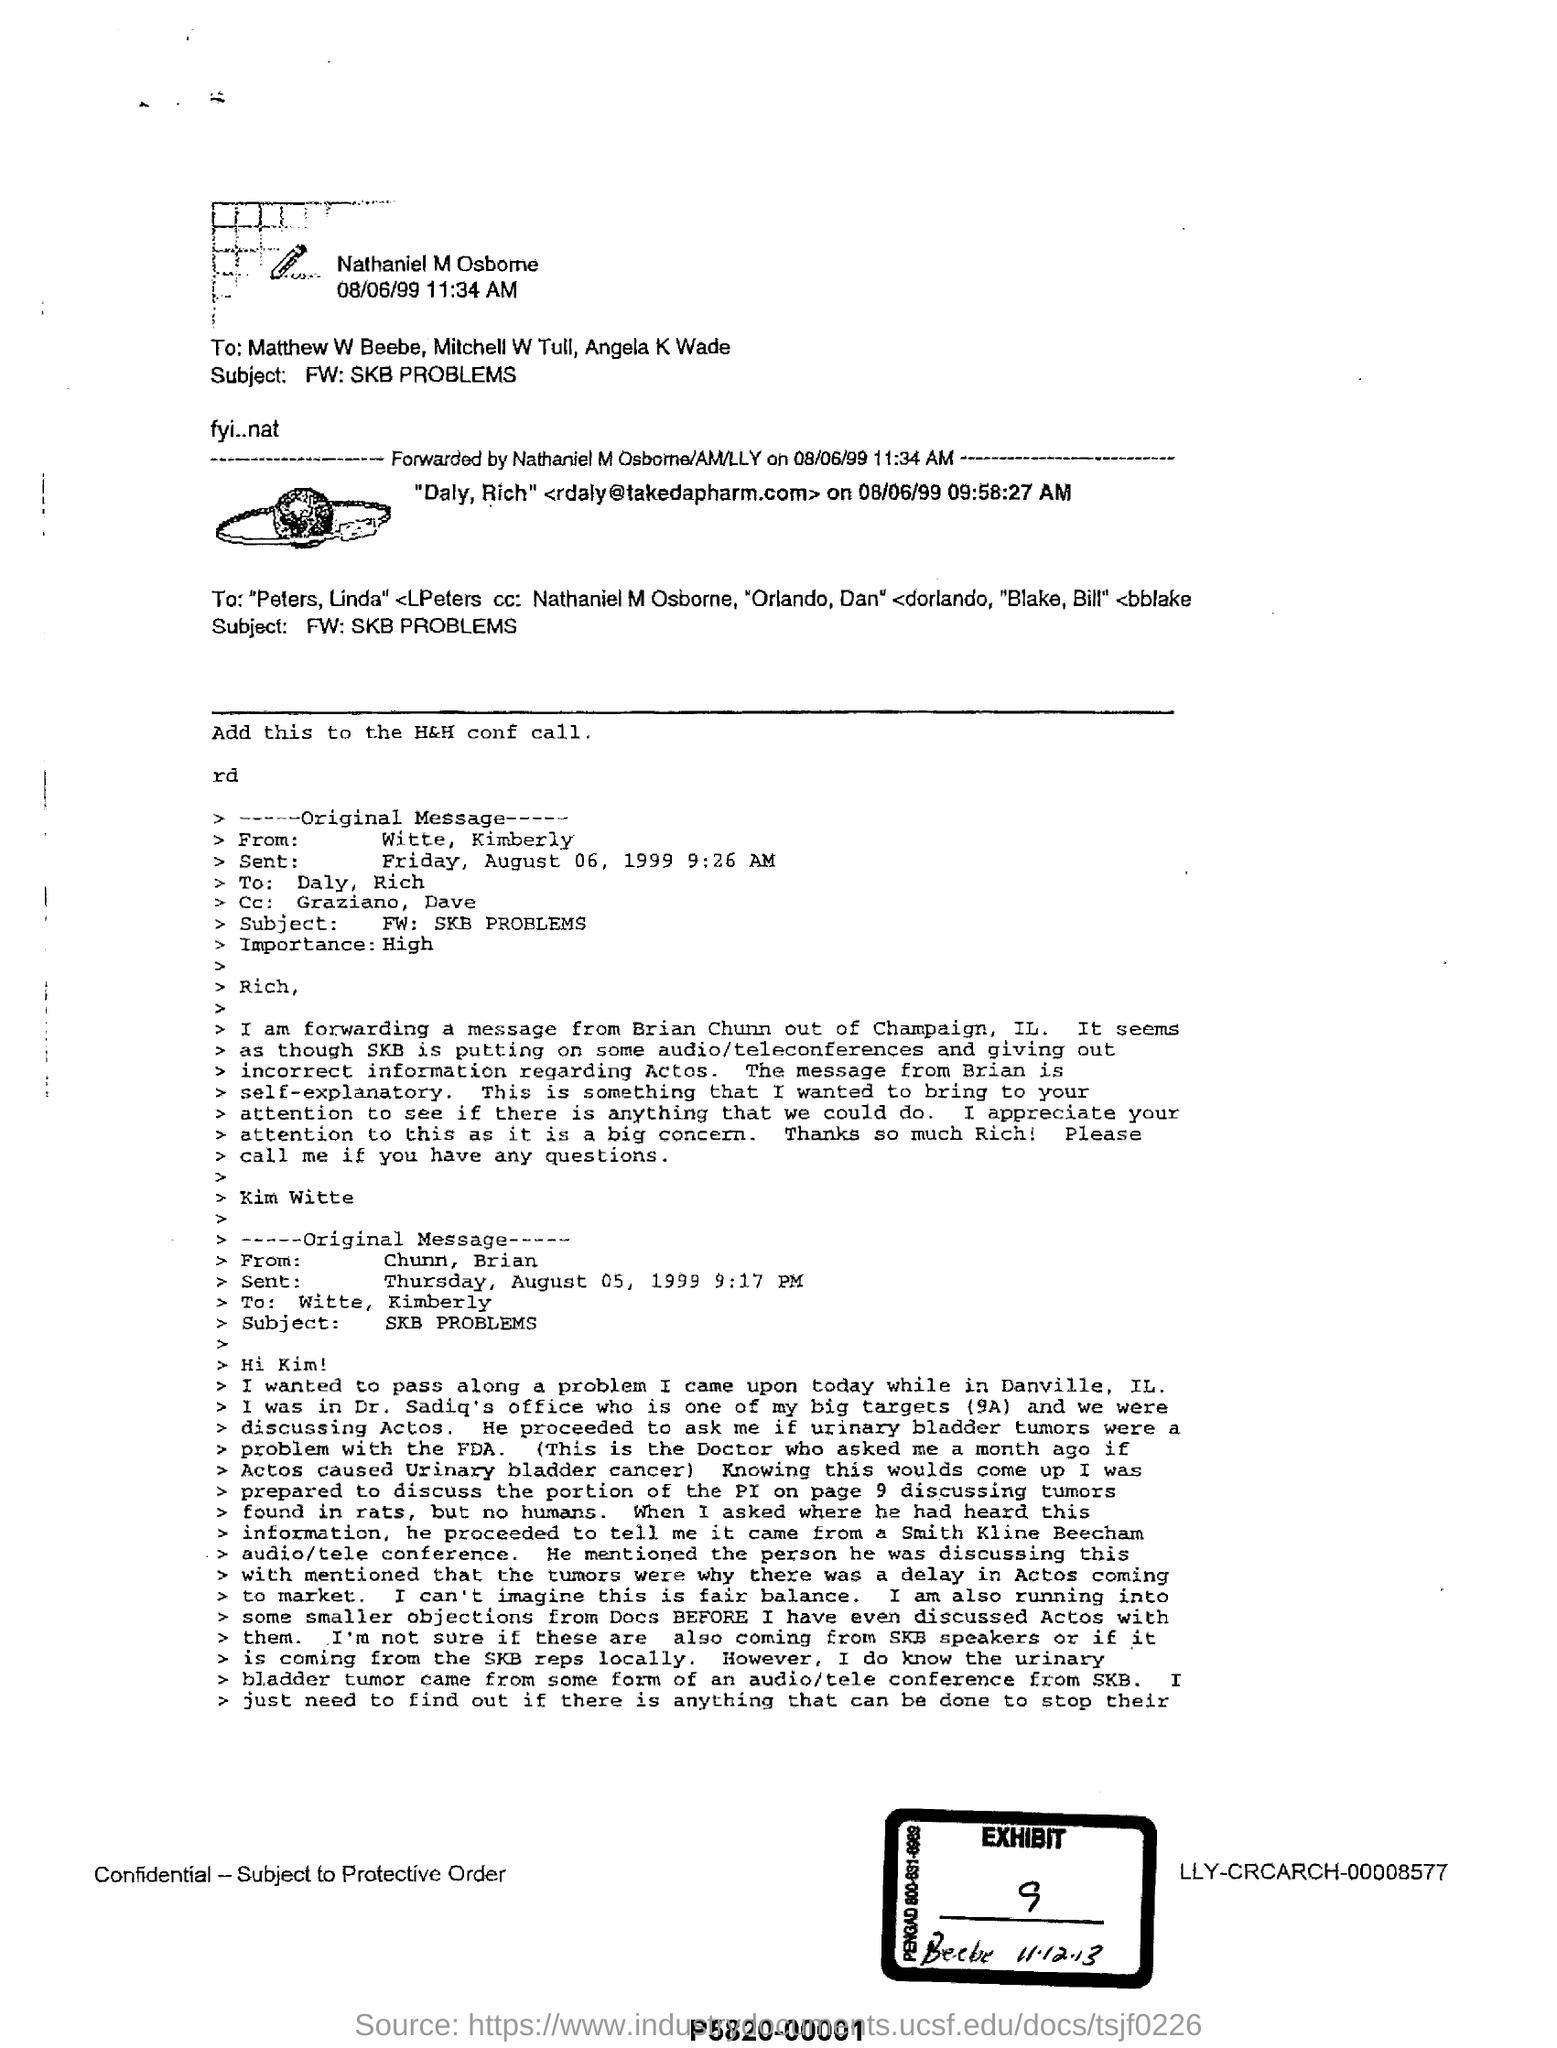What is the level of importance of the email send by Witte, Kimberly?
Offer a terse response. High. What is the subject of the document?
Offer a very short reply. FW: SKB PROBLEMS. What is the EXHIBIT number mentioned?
Make the answer very short. 9. What is the exhibit no given in the document?
Your response must be concise. 9. 